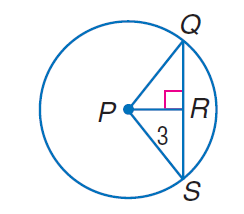Answer the mathemtical geometry problem and directly provide the correct option letter.
Question: The radius of \odot P is 5 and P R = 3. Find Q S.
Choices: A: 3 B: 5 C: 6 D: 8 D 